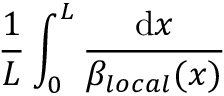<formula> <loc_0><loc_0><loc_500><loc_500>\frac { 1 } { L } \int _ { 0 } ^ { L } \frac { d x } { \beta _ { l o c a l } ( x ) }</formula> 